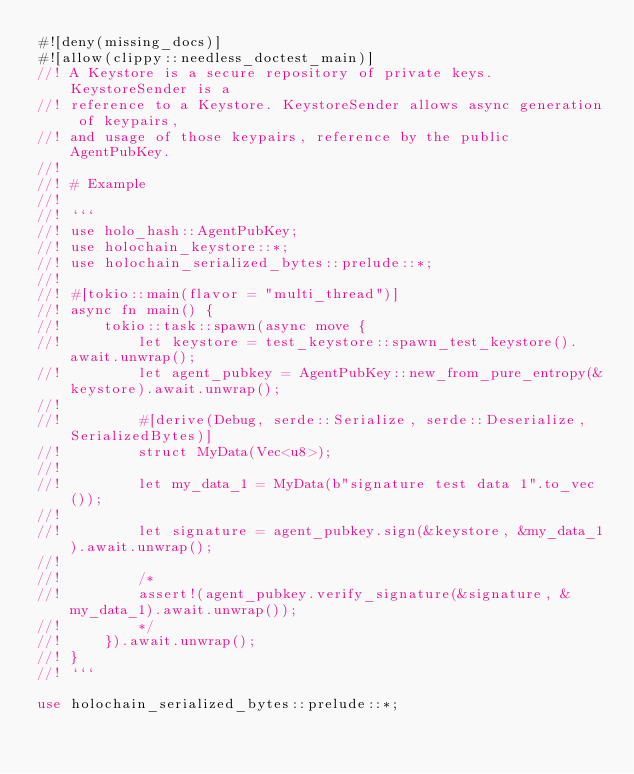Convert code to text. <code><loc_0><loc_0><loc_500><loc_500><_Rust_>#![deny(missing_docs)]
#![allow(clippy::needless_doctest_main)]
//! A Keystore is a secure repository of private keys. KeystoreSender is a
//! reference to a Keystore. KeystoreSender allows async generation of keypairs,
//! and usage of those keypairs, reference by the public AgentPubKey.
//!
//! # Example
//!
//! ```
//! use holo_hash::AgentPubKey;
//! use holochain_keystore::*;
//! use holochain_serialized_bytes::prelude::*;
//!
//! #[tokio::main(flavor = "multi_thread")]
//! async fn main() {
//!     tokio::task::spawn(async move {
//!         let keystore = test_keystore::spawn_test_keystore().await.unwrap();
//!         let agent_pubkey = AgentPubKey::new_from_pure_entropy(&keystore).await.unwrap();
//!
//!         #[derive(Debug, serde::Serialize, serde::Deserialize, SerializedBytes)]
//!         struct MyData(Vec<u8>);
//!
//!         let my_data_1 = MyData(b"signature test data 1".to_vec());
//!
//!         let signature = agent_pubkey.sign(&keystore, &my_data_1).await.unwrap();
//!
//!         /*
//!         assert!(agent_pubkey.verify_signature(&signature, &my_data_1).await.unwrap());
//!         */
//!     }).await.unwrap();
//! }
//! ```

use holochain_serialized_bytes::prelude::*;
</code> 